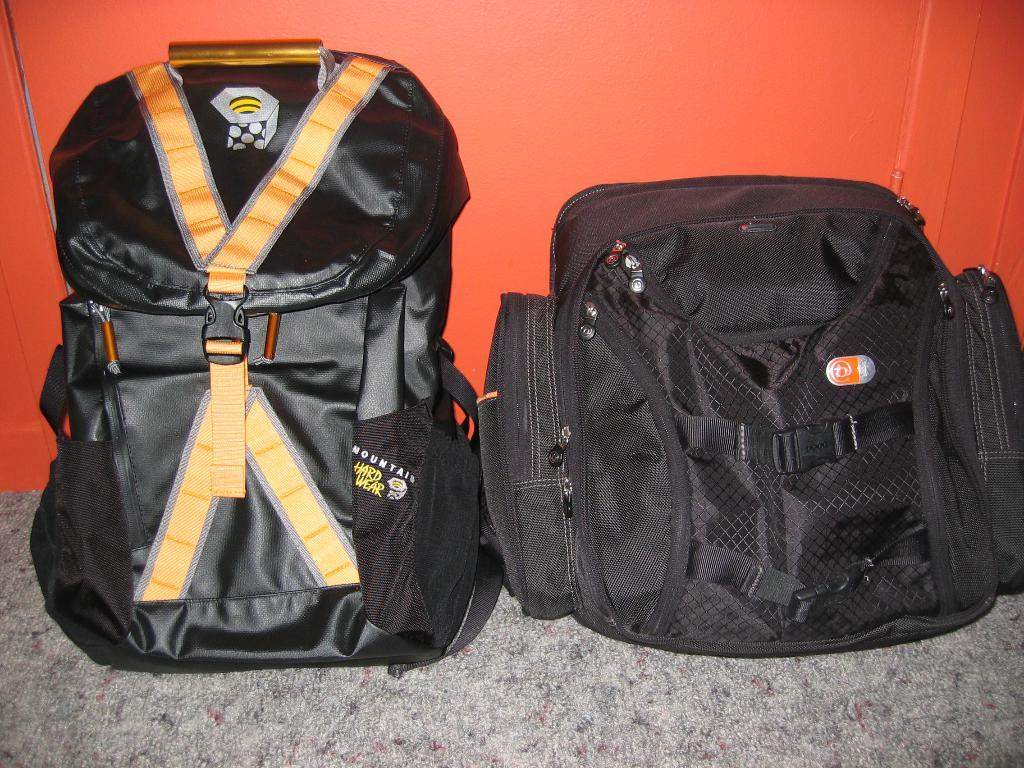How many bags are visible in the image? There are two black color bags in the image. What features do the bags have? The bags have straps, zips, and handlers. Where are the bags located in the image? The bags are placed on the floor. What can be seen in the background of the image? There is an orange color wall in the background of the image. What type of insect can be seen crawling on the bags in the image? There are no insects visible in the image; the bags are placed on the floor with no insects present. 